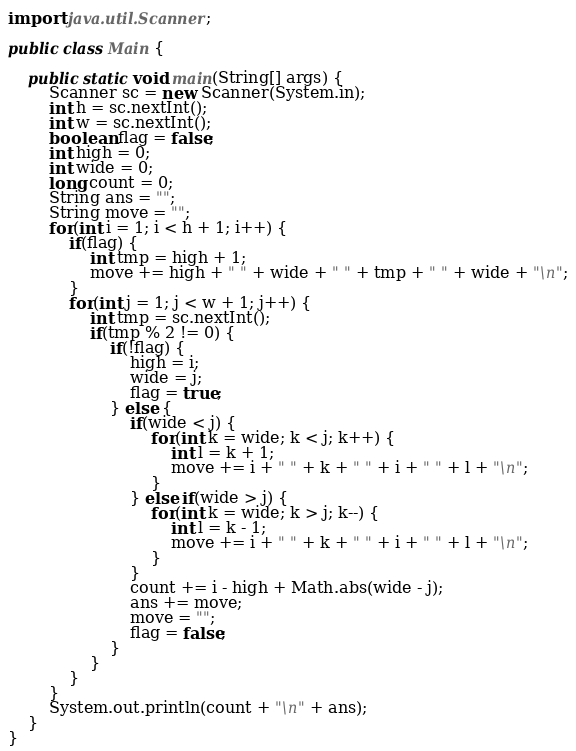Convert code to text. <code><loc_0><loc_0><loc_500><loc_500><_Java_>
import java.util.Scanner;

public class Main {

	public static void main(String[] args) {
		Scanner sc = new Scanner(System.in);
		int h = sc.nextInt();
		int w = sc.nextInt();
		boolean flag = false;
		int high = 0;
		int wide = 0;
		long count = 0;
		String ans = "";
		String move = "";
		for(int i = 1; i < h + 1; i++) {
			if(flag) {
				int tmp = high + 1;
				move += high + " " + wide + " " + tmp + " " + wide + "\n";
			}
			for(int j = 1; j < w + 1; j++) {
				int tmp = sc.nextInt();
				if(tmp % 2 != 0) {
					if(!flag) {
						high = i;
						wide = j;
						flag = true;
					} else {
						if(wide < j) {
							for(int k = wide; k < j; k++) {
								int l = k + 1;
								move += i + " " + k + " " + i + " " + l + "\n";
							}
						} else if(wide > j) {
							for(int k = wide; k > j; k--) {
								int l = k - 1;
								move += i + " " + k + " " + i + " " + l + "\n";
							}
						}
						count += i - high + Math.abs(wide - j);
						ans += move;
						move = "";
						flag = false;
					}
				}
			}
		}
		System.out.println(count + "\n" + ans);
	}
}</code> 